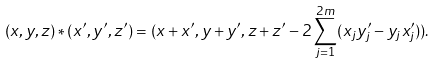Convert formula to latex. <formula><loc_0><loc_0><loc_500><loc_500>( x , y , z ) * ( x ^ { \prime } , y ^ { \prime } , z ^ { \prime } ) = ( x + x ^ { \prime } , y + y ^ { \prime } , z + z ^ { \prime } - 2 \sum _ { j = 1 } ^ { 2 m } ( x _ { j } y _ { j } ^ { \prime } - y _ { j } x _ { j } ^ { \prime } ) ) .</formula> 